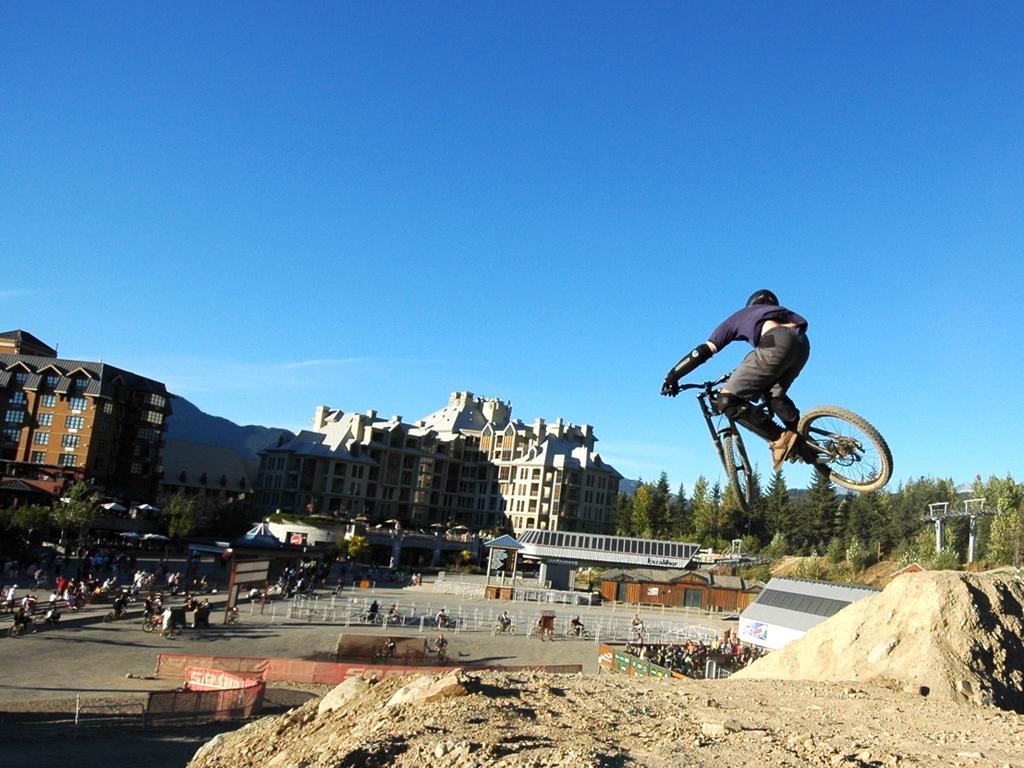How would you summarize this image in a sentence or two? There is a fence, people, and bicycles at the bottom of this image. We can see trees and buildings in the middle of this image. There is one man on the bicycle is on the right side of this image, and there is a blue sky at the top of this image. 